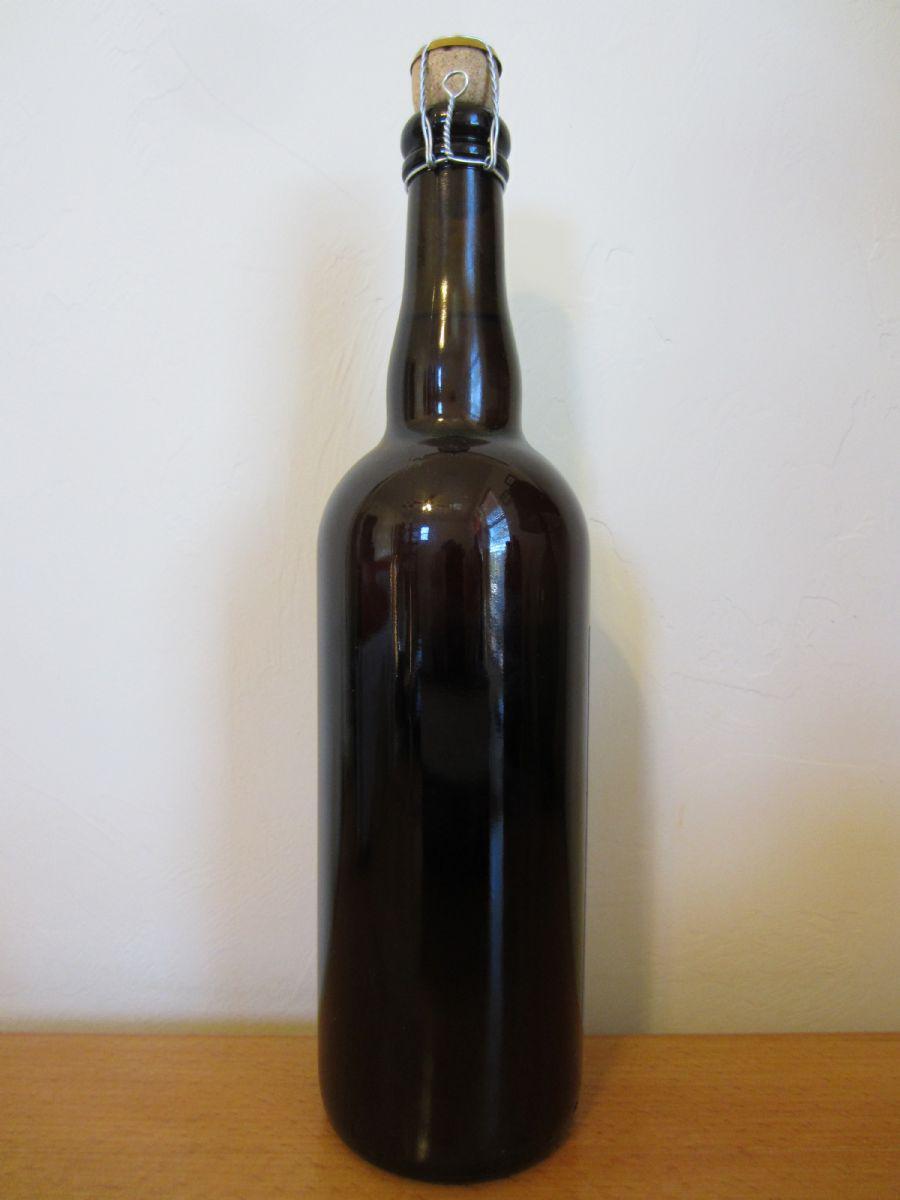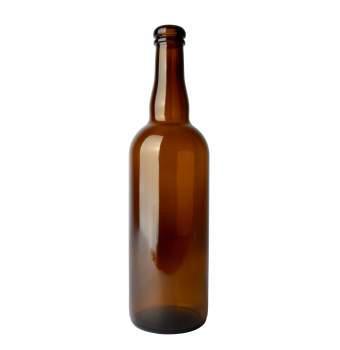The first image is the image on the left, the second image is the image on the right. Evaluate the accuracy of this statement regarding the images: "There is only one bottle in at least one of the images.". Is it true? Answer yes or no. Yes. The first image is the image on the left, the second image is the image on the right. Given the left and right images, does the statement "There are more bottles in the image on the right." hold true? Answer yes or no. No. 